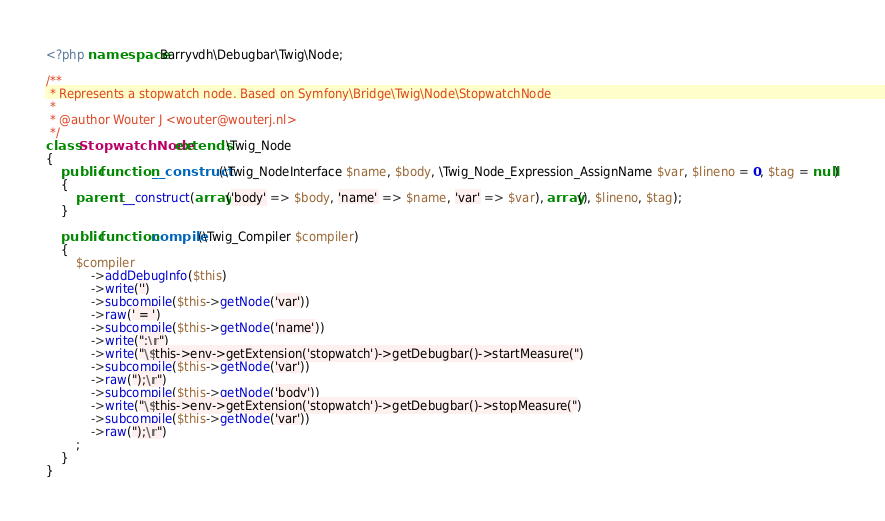Convert code to text. <code><loc_0><loc_0><loc_500><loc_500><_PHP_><?php namespace Barryvdh\Debugbar\Twig\Node;

/**
 * Represents a stopwatch node. Based on Symfony\Bridge\Twig\Node\StopwatchNode
 *
 * @author Wouter J <wouter@wouterj.nl>
 */
class StopwatchNode extends \Twig_Node
{
    public function __construct(\Twig_NodeInterface $name, $body, \Twig_Node_Expression_AssignName $var, $lineno = 0, $tag = null)
    {
        parent::__construct(array('body' => $body, 'name' => $name, 'var' => $var), array(), $lineno, $tag);
    }

    public function compile(\Twig_Compiler $compiler)
    {
        $compiler
            ->addDebugInfo($this)
            ->write('')
            ->subcompile($this->getNode('var'))
            ->raw(' = ')
            ->subcompile($this->getNode('name'))
            ->write(";\n")
            ->write("\$this->env->getExtension('stopwatch')->getDebugbar()->startMeasure(")
            ->subcompile($this->getNode('var'))
            ->raw(");\n")
            ->subcompile($this->getNode('body'))
            ->write("\$this->env->getExtension('stopwatch')->getDebugbar()->stopMeasure(")
            ->subcompile($this->getNode('var'))
            ->raw(");\n")
        ;
    }
}
</code> 